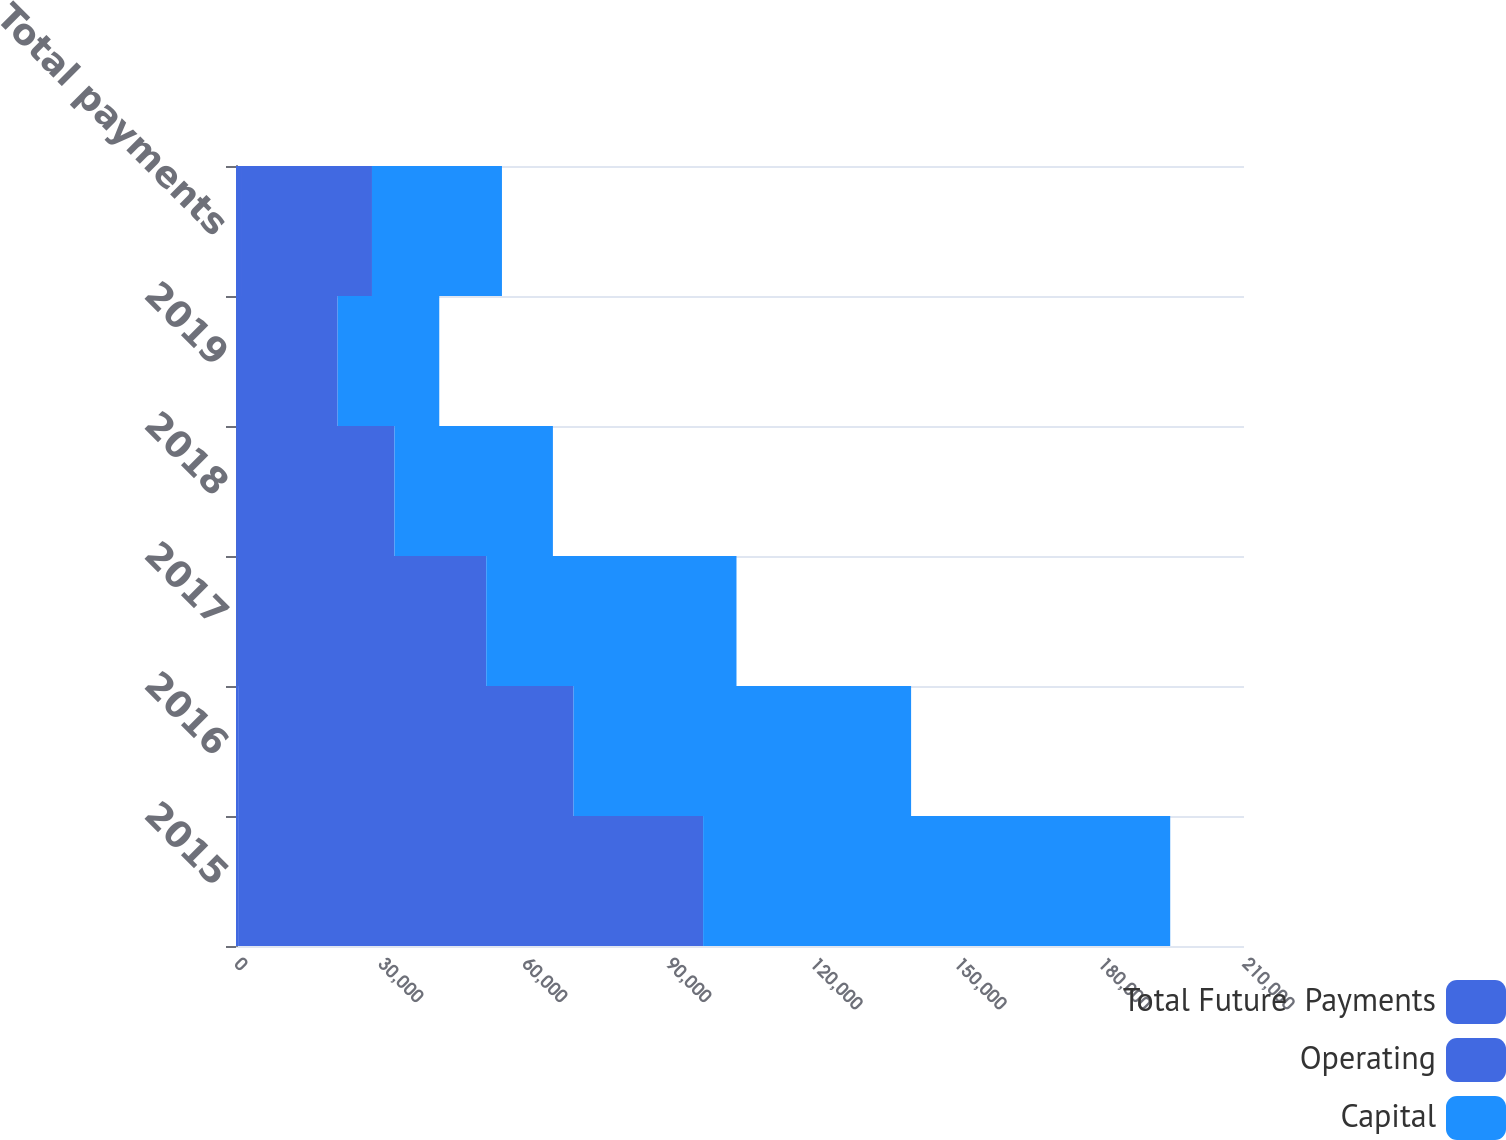<chart> <loc_0><loc_0><loc_500><loc_500><stacked_bar_chart><ecel><fcel>2015<fcel>2016<fcel>2017<fcel>2018<fcel>2019<fcel>Total payments<nl><fcel>Total Future  Payments<fcel>441<fcel>448<fcel>323<fcel>26<fcel>10<fcel>1248<nl><fcel>Operating<fcel>96873<fcel>69875<fcel>51811<fcel>32985<fcel>21164<fcel>27079.5<nl><fcel>Capital<fcel>97314<fcel>70323<fcel>52134<fcel>33011<fcel>21174<fcel>27079.5<nl></chart> 